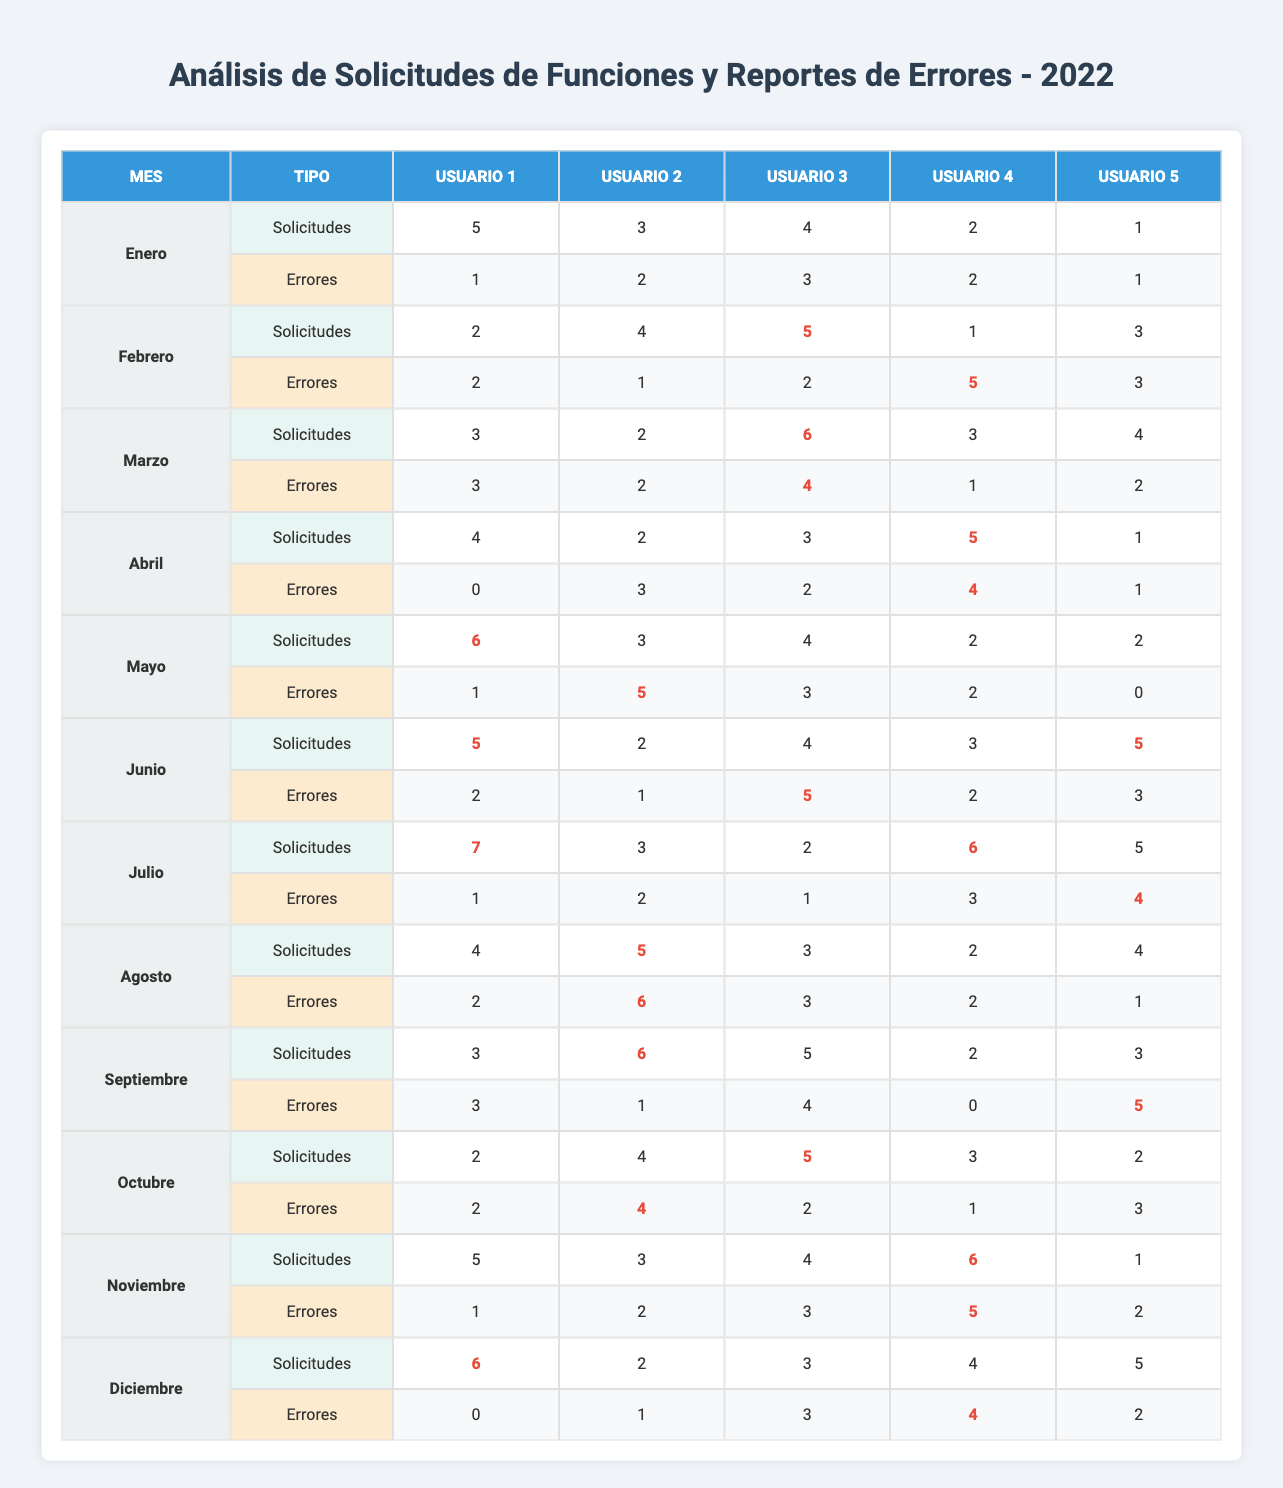¿Qué usuario tuvo la mayor cantidad de solicitudes de funciones en julio? En julio, se ve que User1 tuvo 7 solicitudes, que es más que los 6 de User4 y los 5 de User5. Por ende, User1 tiene la mayor cantidad de solicitudes en este mes.
Answer: User1 ¿Cuántas solicitudes de funciones recibió User3 en diciembre? En diciembre, la tabla muestra que User3 tuvo 3 solicitudes, lo que se puede ver directamente.
Answer: 3 ¿Cuál fue el promedio de errores reportados por User2 en el primer trimestre (enero, febrero, marzo)? Sumar los errores: enero (2) + febrero (1) + marzo (2) = 5. Luego, para calcular el promedio: 5 ÷ 3 = 1.67.
Answer: 1.67 ¿Qué mes tuvo el mayor número de solicitudes de funciones y cuántas fueron? Al revisar cada mes, encontramos que julio tuvo el mayor número de solicitudes con un total de 7 por User1.
Answer: Julio, 7 ¿Fue el número de errores reportados por User4 más alto en marzo que en abril? En marzo, User4 reportó 1 error, mientras que en abril reportó 4. Esto indica que el número de errores en abril fue más alto que en marzo.
Answer: No ¿Cuántas solicitudes de funciones se recibieron en total durante el mes de agosto? Sumando las solicitudes de User1 (4), User2 (5), User3 (3), User4 (2), y User5 (4): 4 + 5 + 3 + 2 + 4 = 18.
Answer: 18 ¿Qué usuario reportó el menor número de errores en mayo? En mayo, User5 reportó 0 errores, que es el menor número frente a los informes de los otros usuarios.
Answer: User5 ¿Cuántos errores reportó User1 en el tercer trimestre (julio, agosto, septiembre)? Sumando los errores en los meses de julio (1), agosto (2) y septiembre (3) se obtiene: 1 + 2 + 3 = 6.
Answer: 6 ¿Hubo algún mes en el que User3 no hiciera solicitudes de funciones? Al revisar la tabla, se puede ver que User3 hizo solicitudes todos los meses, por lo que la respuesta es no.
Answer: No ¿Cuál fue la diferencia entre la cantidad de errores reportados en enero y diciembre por User4? User4 reportó 2 errores en enero y 4 en diciembre, así que la diferencia es 4 - 2 = 2.
Answer: 2 